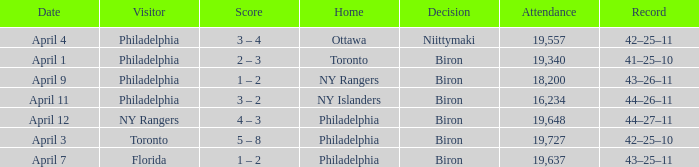Who were the visitors when the home team were the ny rangers? Philadelphia. 